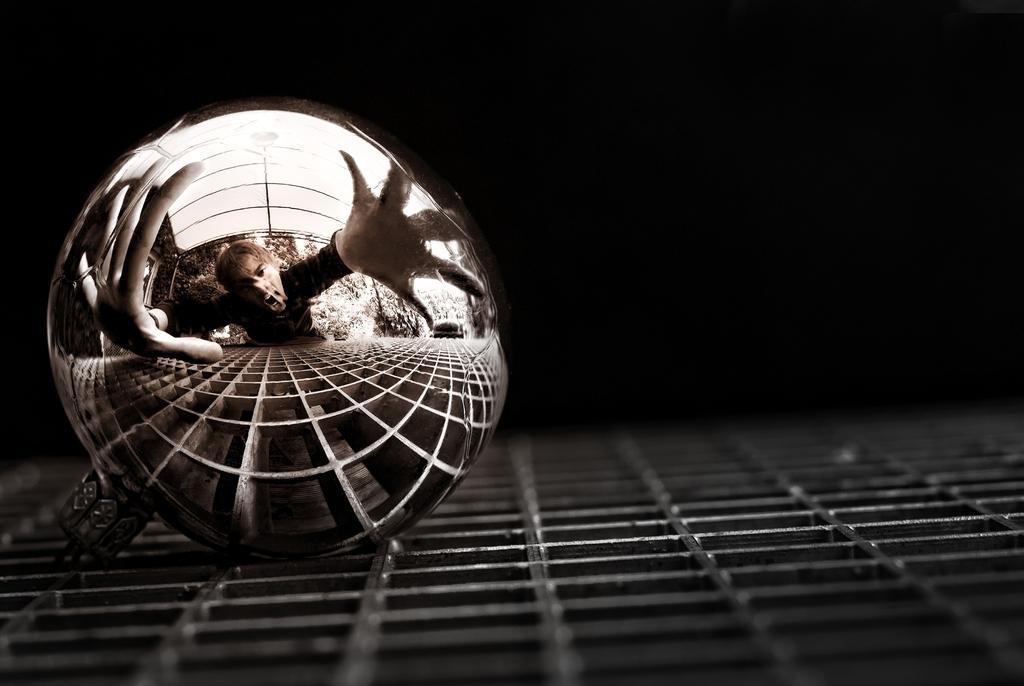Please provide a concise description of this image. Background portion of the picture is dark. In this picture we can see the reflection on an object. We can see a person, trees and few objects. At the bottom portion of the picture we can see metal object. 